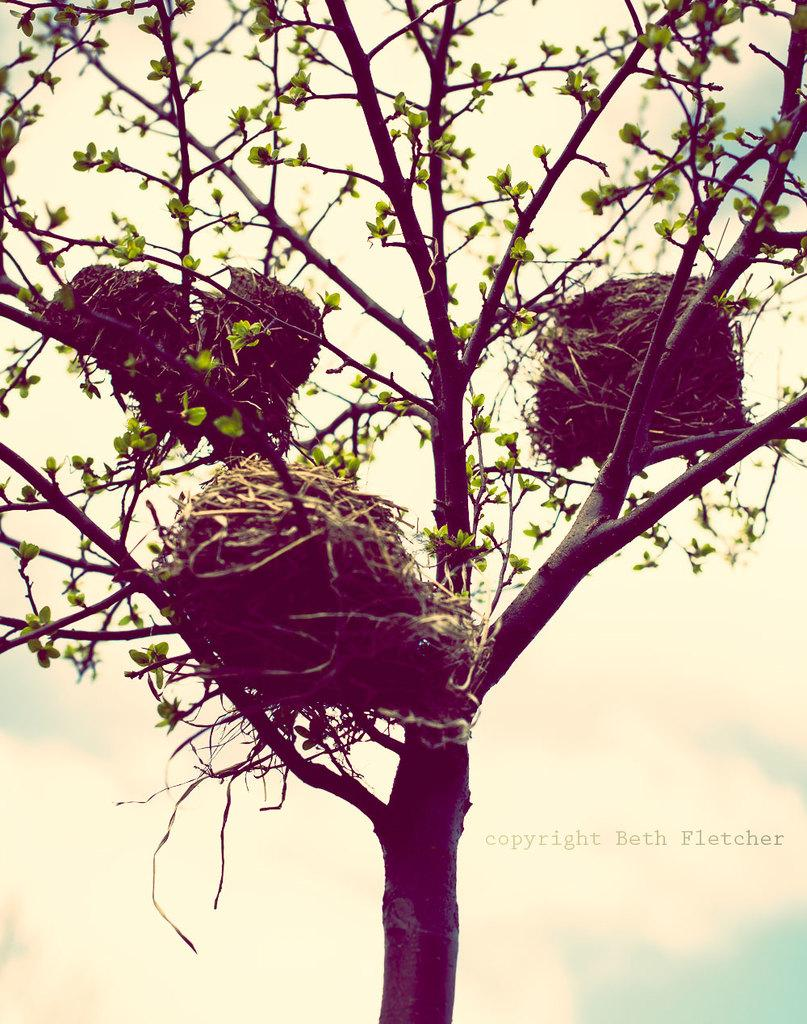What can be seen on the tree in the image? There are nests on a tree in the image. Is there any additional information or marking on the image? Yes, there is a watermark in the image. How many plates are stacked on the tree in the image? There are no plates present in the image; it features nests on a tree. Is the environment depicted in the image quiet or noisy? The image does not provide any information about the noise level in the environment. 